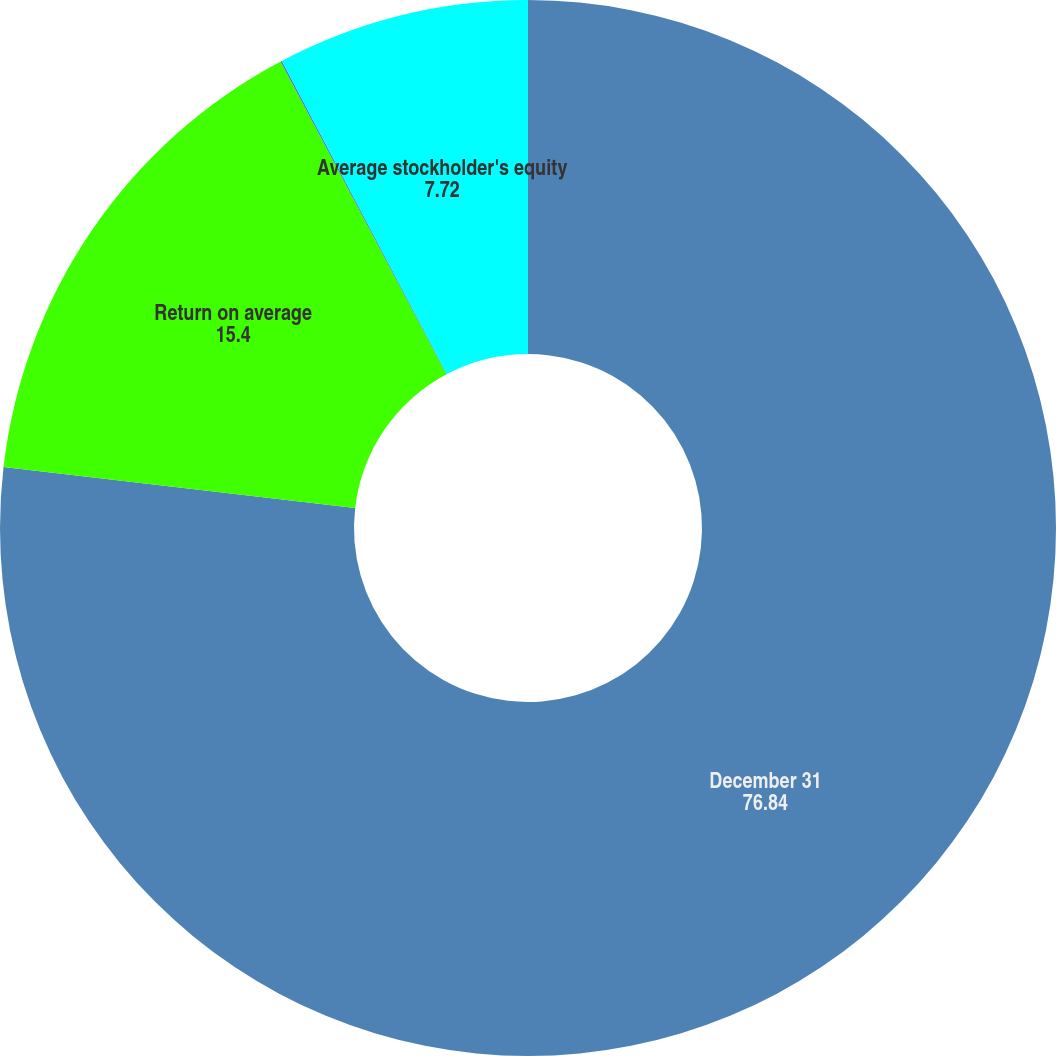Convert chart to OTSL. <chart><loc_0><loc_0><loc_500><loc_500><pie_chart><fcel>December 31<fcel>Return on average<fcel>Return on average total assets<fcel>Average stockholder's equity<nl><fcel>76.84%<fcel>15.4%<fcel>0.04%<fcel>7.72%<nl></chart> 